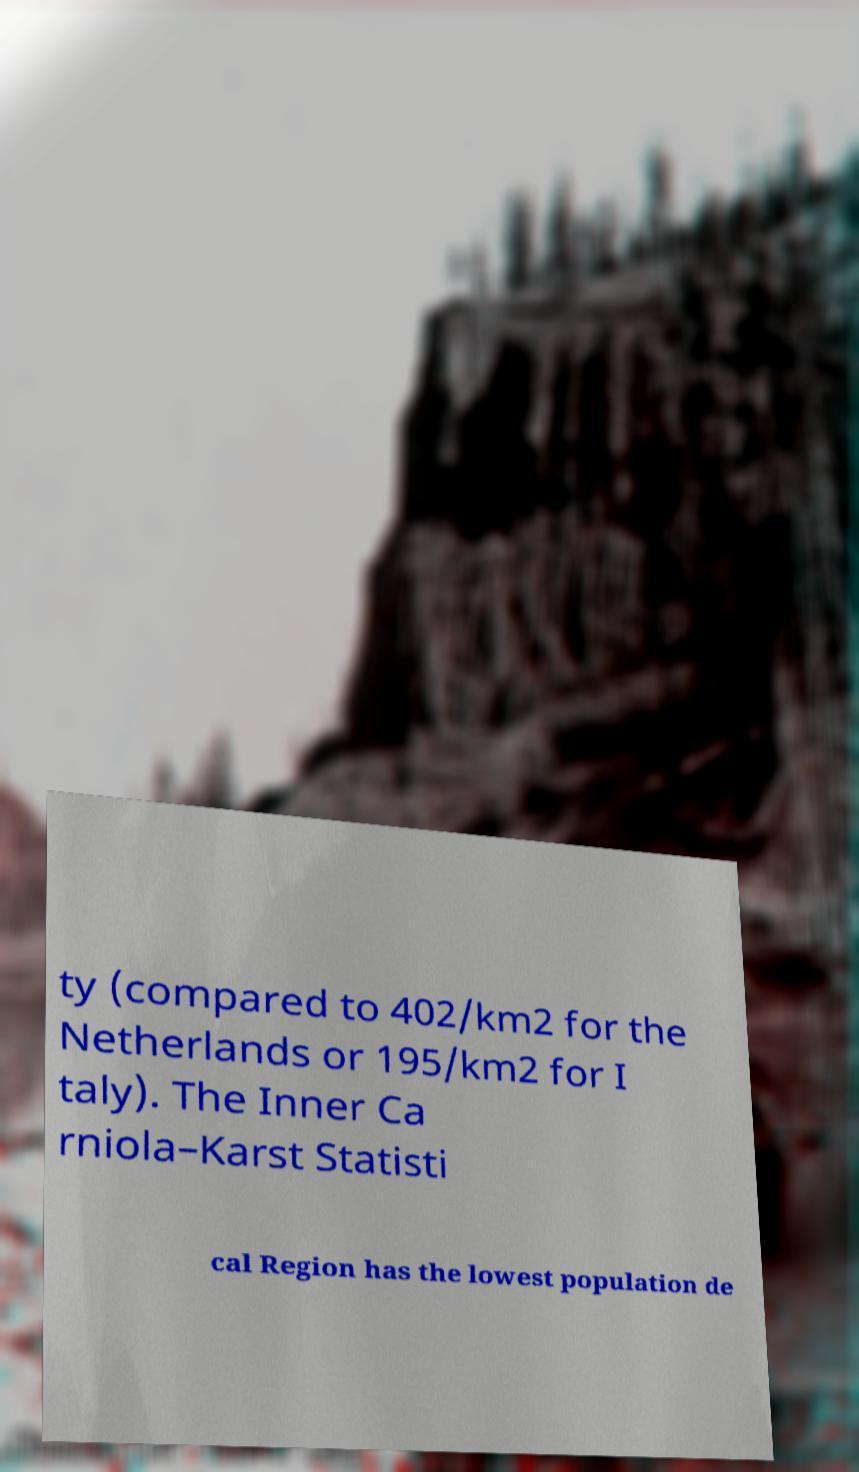Could you assist in decoding the text presented in this image and type it out clearly? ty (compared to 402/km2 for the Netherlands or 195/km2 for I taly). The Inner Ca rniola–Karst Statisti cal Region has the lowest population de 